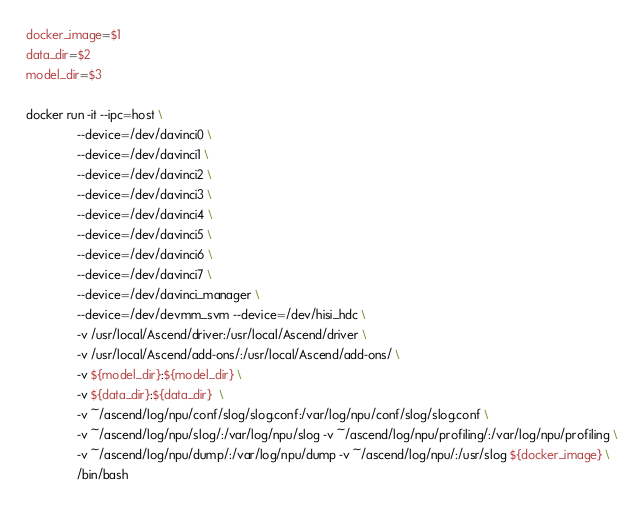Convert code to text. <code><loc_0><loc_0><loc_500><loc_500><_Bash_>docker_image=$1
data_dir=$2
model_dir=$3

docker run -it --ipc=host \
               --device=/dev/davinci0 \
               --device=/dev/davinci1 \
               --device=/dev/davinci2 \
               --device=/dev/davinci3 \
               --device=/dev/davinci4 \
               --device=/dev/davinci5 \
               --device=/dev/davinci6 \
               --device=/dev/davinci7 \
               --device=/dev/davinci_manager \
               --device=/dev/devmm_svm --device=/dev/hisi_hdc \
               -v /usr/local/Ascend/driver:/usr/local/Ascend/driver \
               -v /usr/local/Ascend/add-ons/:/usr/local/Ascend/add-ons/ \
               -v ${model_dir}:${model_dir} \
               -v ${data_dir}:${data_dir}  \
               -v ~/ascend/log/npu/conf/slog/slog.conf:/var/log/npu/conf/slog/slog.conf \
               -v ~/ascend/log/npu/slog/:/var/log/npu/slog -v ~/ascend/log/npu/profiling/:/var/log/npu/profiling \
               -v ~/ascend/log/npu/dump/:/var/log/npu/dump -v ~/ascend/log/npu/:/usr/slog ${docker_image} \
               /bin/bash
</code> 